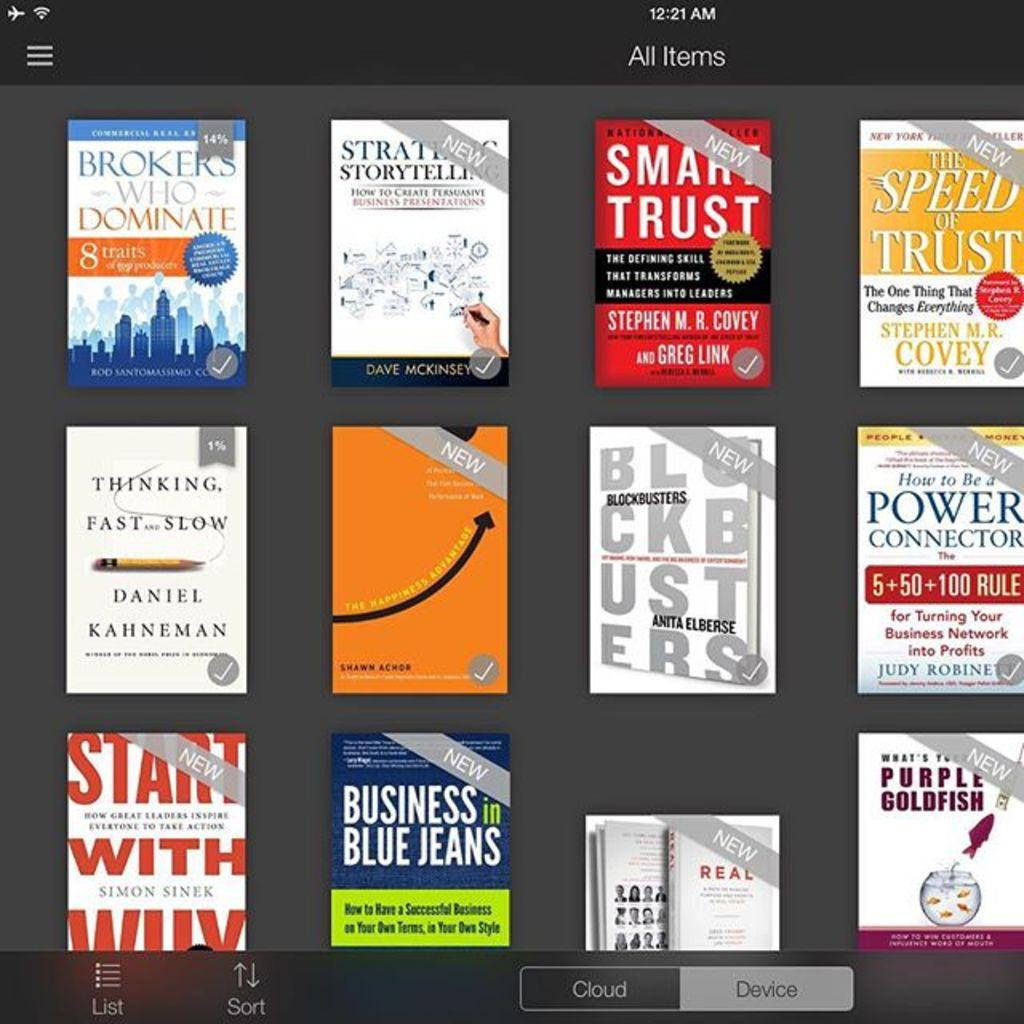<image>
Render a clear and concise summary of the photo. 12 books about business and trust, thinking and brokering are displayed on a screen 